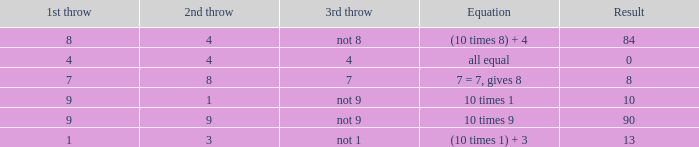What is the equation where the 3rd throw is 7? 7 = 7, gives 8. 